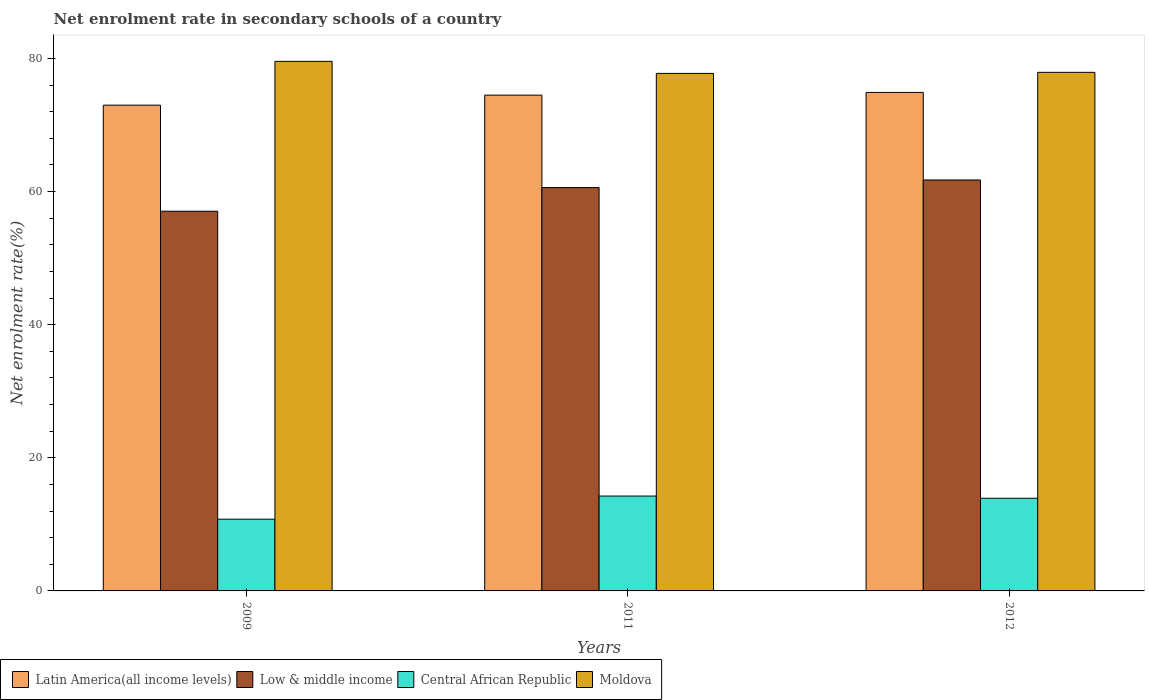How many different coloured bars are there?
Your response must be concise. 4. What is the net enrolment rate in secondary schools in Latin America(all income levels) in 2009?
Your answer should be very brief. 72.98. Across all years, what is the maximum net enrolment rate in secondary schools in Moldova?
Offer a terse response. 79.56. Across all years, what is the minimum net enrolment rate in secondary schools in Low & middle income?
Your answer should be very brief. 57.04. What is the total net enrolment rate in secondary schools in Moldova in the graph?
Give a very brief answer. 235.22. What is the difference between the net enrolment rate in secondary schools in Low & middle income in 2011 and that in 2012?
Offer a very short reply. -1.14. What is the difference between the net enrolment rate in secondary schools in Central African Republic in 2011 and the net enrolment rate in secondary schools in Moldova in 2012?
Give a very brief answer. -63.66. What is the average net enrolment rate in secondary schools in Low & middle income per year?
Provide a short and direct response. 59.79. In the year 2009, what is the difference between the net enrolment rate in secondary schools in Moldova and net enrolment rate in secondary schools in Latin America(all income levels)?
Offer a very short reply. 6.58. What is the ratio of the net enrolment rate in secondary schools in Central African Republic in 2009 to that in 2011?
Your response must be concise. 0.76. What is the difference between the highest and the second highest net enrolment rate in secondary schools in Latin America(all income levels)?
Provide a short and direct response. 0.41. What is the difference between the highest and the lowest net enrolment rate in secondary schools in Moldova?
Make the answer very short. 1.81. Is the sum of the net enrolment rate in secondary schools in Moldova in 2011 and 2012 greater than the maximum net enrolment rate in secondary schools in Low & middle income across all years?
Your answer should be compact. Yes. Is it the case that in every year, the sum of the net enrolment rate in secondary schools in Central African Republic and net enrolment rate in secondary schools in Moldova is greater than the sum of net enrolment rate in secondary schools in Latin America(all income levels) and net enrolment rate in secondary schools in Low & middle income?
Keep it short and to the point. No. What does the 3rd bar from the left in 2012 represents?
Offer a very short reply. Central African Republic. How many bars are there?
Offer a terse response. 12. Where does the legend appear in the graph?
Your answer should be very brief. Bottom left. What is the title of the graph?
Your response must be concise. Net enrolment rate in secondary schools of a country. Does "Guatemala" appear as one of the legend labels in the graph?
Keep it short and to the point. No. What is the label or title of the X-axis?
Offer a very short reply. Years. What is the label or title of the Y-axis?
Give a very brief answer. Net enrolment rate(%). What is the Net enrolment rate(%) in Latin America(all income levels) in 2009?
Provide a short and direct response. 72.98. What is the Net enrolment rate(%) of Low & middle income in 2009?
Offer a terse response. 57.04. What is the Net enrolment rate(%) in Central African Republic in 2009?
Keep it short and to the point. 10.78. What is the Net enrolment rate(%) of Moldova in 2009?
Offer a very short reply. 79.56. What is the Net enrolment rate(%) in Latin America(all income levels) in 2011?
Make the answer very short. 74.48. What is the Net enrolment rate(%) in Low & middle income in 2011?
Make the answer very short. 60.59. What is the Net enrolment rate(%) of Central African Republic in 2011?
Offer a very short reply. 14.25. What is the Net enrolment rate(%) of Moldova in 2011?
Your response must be concise. 77.75. What is the Net enrolment rate(%) in Latin America(all income levels) in 2012?
Provide a short and direct response. 74.89. What is the Net enrolment rate(%) in Low & middle income in 2012?
Give a very brief answer. 61.74. What is the Net enrolment rate(%) in Central African Republic in 2012?
Provide a succinct answer. 13.92. What is the Net enrolment rate(%) in Moldova in 2012?
Offer a very short reply. 77.91. Across all years, what is the maximum Net enrolment rate(%) of Latin America(all income levels)?
Your answer should be compact. 74.89. Across all years, what is the maximum Net enrolment rate(%) of Low & middle income?
Keep it short and to the point. 61.74. Across all years, what is the maximum Net enrolment rate(%) of Central African Republic?
Your answer should be compact. 14.25. Across all years, what is the maximum Net enrolment rate(%) of Moldova?
Keep it short and to the point. 79.56. Across all years, what is the minimum Net enrolment rate(%) in Latin America(all income levels)?
Provide a short and direct response. 72.98. Across all years, what is the minimum Net enrolment rate(%) of Low & middle income?
Make the answer very short. 57.04. Across all years, what is the minimum Net enrolment rate(%) in Central African Republic?
Your answer should be compact. 10.78. Across all years, what is the minimum Net enrolment rate(%) in Moldova?
Keep it short and to the point. 77.75. What is the total Net enrolment rate(%) in Latin America(all income levels) in the graph?
Your answer should be very brief. 222.35. What is the total Net enrolment rate(%) of Low & middle income in the graph?
Give a very brief answer. 179.38. What is the total Net enrolment rate(%) of Central African Republic in the graph?
Make the answer very short. 38.95. What is the total Net enrolment rate(%) of Moldova in the graph?
Your answer should be very brief. 235.22. What is the difference between the Net enrolment rate(%) of Latin America(all income levels) in 2009 and that in 2011?
Your response must be concise. -1.51. What is the difference between the Net enrolment rate(%) of Low & middle income in 2009 and that in 2011?
Provide a succinct answer. -3.55. What is the difference between the Net enrolment rate(%) of Central African Republic in 2009 and that in 2011?
Offer a very short reply. -3.47. What is the difference between the Net enrolment rate(%) in Moldova in 2009 and that in 2011?
Give a very brief answer. 1.81. What is the difference between the Net enrolment rate(%) of Latin America(all income levels) in 2009 and that in 2012?
Provide a short and direct response. -1.91. What is the difference between the Net enrolment rate(%) of Low & middle income in 2009 and that in 2012?
Provide a succinct answer. -4.7. What is the difference between the Net enrolment rate(%) of Central African Republic in 2009 and that in 2012?
Your response must be concise. -3.15. What is the difference between the Net enrolment rate(%) in Moldova in 2009 and that in 2012?
Provide a succinct answer. 1.65. What is the difference between the Net enrolment rate(%) in Latin America(all income levels) in 2011 and that in 2012?
Offer a terse response. -0.41. What is the difference between the Net enrolment rate(%) of Low & middle income in 2011 and that in 2012?
Make the answer very short. -1.14. What is the difference between the Net enrolment rate(%) in Central African Republic in 2011 and that in 2012?
Provide a short and direct response. 0.33. What is the difference between the Net enrolment rate(%) in Moldova in 2011 and that in 2012?
Your response must be concise. -0.16. What is the difference between the Net enrolment rate(%) of Latin America(all income levels) in 2009 and the Net enrolment rate(%) of Low & middle income in 2011?
Your response must be concise. 12.38. What is the difference between the Net enrolment rate(%) in Latin America(all income levels) in 2009 and the Net enrolment rate(%) in Central African Republic in 2011?
Your response must be concise. 58.73. What is the difference between the Net enrolment rate(%) in Latin America(all income levels) in 2009 and the Net enrolment rate(%) in Moldova in 2011?
Offer a terse response. -4.77. What is the difference between the Net enrolment rate(%) in Low & middle income in 2009 and the Net enrolment rate(%) in Central African Republic in 2011?
Make the answer very short. 42.79. What is the difference between the Net enrolment rate(%) of Low & middle income in 2009 and the Net enrolment rate(%) of Moldova in 2011?
Give a very brief answer. -20.71. What is the difference between the Net enrolment rate(%) of Central African Republic in 2009 and the Net enrolment rate(%) of Moldova in 2011?
Ensure brevity in your answer.  -66.97. What is the difference between the Net enrolment rate(%) of Latin America(all income levels) in 2009 and the Net enrolment rate(%) of Low & middle income in 2012?
Provide a succinct answer. 11.24. What is the difference between the Net enrolment rate(%) of Latin America(all income levels) in 2009 and the Net enrolment rate(%) of Central African Republic in 2012?
Provide a short and direct response. 59.05. What is the difference between the Net enrolment rate(%) of Latin America(all income levels) in 2009 and the Net enrolment rate(%) of Moldova in 2012?
Give a very brief answer. -4.93. What is the difference between the Net enrolment rate(%) in Low & middle income in 2009 and the Net enrolment rate(%) in Central African Republic in 2012?
Provide a succinct answer. 43.12. What is the difference between the Net enrolment rate(%) of Low & middle income in 2009 and the Net enrolment rate(%) of Moldova in 2012?
Your response must be concise. -20.87. What is the difference between the Net enrolment rate(%) in Central African Republic in 2009 and the Net enrolment rate(%) in Moldova in 2012?
Provide a succinct answer. -67.13. What is the difference between the Net enrolment rate(%) in Latin America(all income levels) in 2011 and the Net enrolment rate(%) in Low & middle income in 2012?
Offer a terse response. 12.74. What is the difference between the Net enrolment rate(%) in Latin America(all income levels) in 2011 and the Net enrolment rate(%) in Central African Republic in 2012?
Provide a short and direct response. 60.56. What is the difference between the Net enrolment rate(%) of Latin America(all income levels) in 2011 and the Net enrolment rate(%) of Moldova in 2012?
Provide a short and direct response. -3.43. What is the difference between the Net enrolment rate(%) in Low & middle income in 2011 and the Net enrolment rate(%) in Central African Republic in 2012?
Provide a short and direct response. 46.67. What is the difference between the Net enrolment rate(%) in Low & middle income in 2011 and the Net enrolment rate(%) in Moldova in 2012?
Give a very brief answer. -17.32. What is the difference between the Net enrolment rate(%) in Central African Republic in 2011 and the Net enrolment rate(%) in Moldova in 2012?
Your answer should be compact. -63.66. What is the average Net enrolment rate(%) of Latin America(all income levels) per year?
Offer a terse response. 74.12. What is the average Net enrolment rate(%) in Low & middle income per year?
Your answer should be very brief. 59.79. What is the average Net enrolment rate(%) in Central African Republic per year?
Your response must be concise. 12.98. What is the average Net enrolment rate(%) of Moldova per year?
Ensure brevity in your answer.  78.41. In the year 2009, what is the difference between the Net enrolment rate(%) in Latin America(all income levels) and Net enrolment rate(%) in Low & middle income?
Your response must be concise. 15.93. In the year 2009, what is the difference between the Net enrolment rate(%) in Latin America(all income levels) and Net enrolment rate(%) in Central African Republic?
Make the answer very short. 62.2. In the year 2009, what is the difference between the Net enrolment rate(%) in Latin America(all income levels) and Net enrolment rate(%) in Moldova?
Offer a very short reply. -6.58. In the year 2009, what is the difference between the Net enrolment rate(%) of Low & middle income and Net enrolment rate(%) of Central African Republic?
Provide a short and direct response. 46.26. In the year 2009, what is the difference between the Net enrolment rate(%) in Low & middle income and Net enrolment rate(%) in Moldova?
Give a very brief answer. -22.52. In the year 2009, what is the difference between the Net enrolment rate(%) of Central African Republic and Net enrolment rate(%) of Moldova?
Give a very brief answer. -68.78. In the year 2011, what is the difference between the Net enrolment rate(%) of Latin America(all income levels) and Net enrolment rate(%) of Low & middle income?
Offer a very short reply. 13.89. In the year 2011, what is the difference between the Net enrolment rate(%) of Latin America(all income levels) and Net enrolment rate(%) of Central African Republic?
Provide a short and direct response. 60.23. In the year 2011, what is the difference between the Net enrolment rate(%) of Latin America(all income levels) and Net enrolment rate(%) of Moldova?
Give a very brief answer. -3.27. In the year 2011, what is the difference between the Net enrolment rate(%) of Low & middle income and Net enrolment rate(%) of Central African Republic?
Your response must be concise. 46.34. In the year 2011, what is the difference between the Net enrolment rate(%) in Low & middle income and Net enrolment rate(%) in Moldova?
Offer a very short reply. -17.15. In the year 2011, what is the difference between the Net enrolment rate(%) of Central African Republic and Net enrolment rate(%) of Moldova?
Provide a succinct answer. -63.5. In the year 2012, what is the difference between the Net enrolment rate(%) of Latin America(all income levels) and Net enrolment rate(%) of Low & middle income?
Make the answer very short. 13.15. In the year 2012, what is the difference between the Net enrolment rate(%) in Latin America(all income levels) and Net enrolment rate(%) in Central African Republic?
Give a very brief answer. 60.97. In the year 2012, what is the difference between the Net enrolment rate(%) of Latin America(all income levels) and Net enrolment rate(%) of Moldova?
Ensure brevity in your answer.  -3.02. In the year 2012, what is the difference between the Net enrolment rate(%) in Low & middle income and Net enrolment rate(%) in Central African Republic?
Offer a very short reply. 47.81. In the year 2012, what is the difference between the Net enrolment rate(%) of Low & middle income and Net enrolment rate(%) of Moldova?
Offer a very short reply. -16.17. In the year 2012, what is the difference between the Net enrolment rate(%) of Central African Republic and Net enrolment rate(%) of Moldova?
Your answer should be very brief. -63.98. What is the ratio of the Net enrolment rate(%) of Latin America(all income levels) in 2009 to that in 2011?
Offer a terse response. 0.98. What is the ratio of the Net enrolment rate(%) of Low & middle income in 2009 to that in 2011?
Keep it short and to the point. 0.94. What is the ratio of the Net enrolment rate(%) in Central African Republic in 2009 to that in 2011?
Your answer should be compact. 0.76. What is the ratio of the Net enrolment rate(%) in Moldova in 2009 to that in 2011?
Provide a succinct answer. 1.02. What is the ratio of the Net enrolment rate(%) of Latin America(all income levels) in 2009 to that in 2012?
Offer a terse response. 0.97. What is the ratio of the Net enrolment rate(%) of Low & middle income in 2009 to that in 2012?
Ensure brevity in your answer.  0.92. What is the ratio of the Net enrolment rate(%) of Central African Republic in 2009 to that in 2012?
Provide a succinct answer. 0.77. What is the ratio of the Net enrolment rate(%) in Moldova in 2009 to that in 2012?
Your response must be concise. 1.02. What is the ratio of the Net enrolment rate(%) of Latin America(all income levels) in 2011 to that in 2012?
Offer a very short reply. 0.99. What is the ratio of the Net enrolment rate(%) in Low & middle income in 2011 to that in 2012?
Provide a succinct answer. 0.98. What is the ratio of the Net enrolment rate(%) in Central African Republic in 2011 to that in 2012?
Make the answer very short. 1.02. What is the ratio of the Net enrolment rate(%) of Moldova in 2011 to that in 2012?
Provide a succinct answer. 1. What is the difference between the highest and the second highest Net enrolment rate(%) of Latin America(all income levels)?
Keep it short and to the point. 0.41. What is the difference between the highest and the second highest Net enrolment rate(%) in Low & middle income?
Provide a short and direct response. 1.14. What is the difference between the highest and the second highest Net enrolment rate(%) of Central African Republic?
Keep it short and to the point. 0.33. What is the difference between the highest and the second highest Net enrolment rate(%) of Moldova?
Keep it short and to the point. 1.65. What is the difference between the highest and the lowest Net enrolment rate(%) of Latin America(all income levels)?
Keep it short and to the point. 1.91. What is the difference between the highest and the lowest Net enrolment rate(%) of Low & middle income?
Your answer should be very brief. 4.7. What is the difference between the highest and the lowest Net enrolment rate(%) of Central African Republic?
Offer a very short reply. 3.47. What is the difference between the highest and the lowest Net enrolment rate(%) in Moldova?
Your response must be concise. 1.81. 